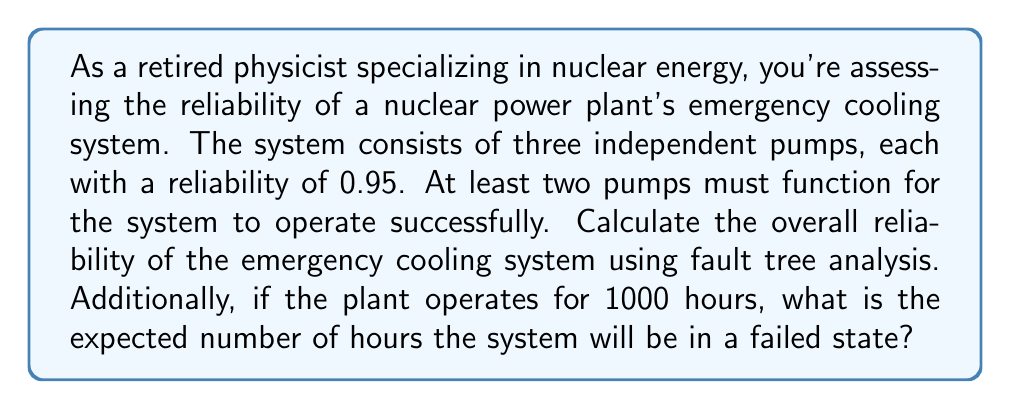Show me your answer to this math problem. Let's approach this problem step-by-step using fault tree analysis and probability theory:

1) First, we need to calculate the probability of system success. The system succeeds if either all three pumps work, or if any two out of three pumps work.

2) Probability of all three pumps working:
   $P(\text{all})$ = $0.95 \times 0.95 \times 0.95$ = $0.95^3$ = $0.857375$

3) Probability of exactly two pumps working:
   There are $\binom{3}{2} = 3$ ways to choose 2 pumps out of 3.
   $P(\text{two})$ = $3 \times 0.95^2 \times 0.05$ = $0.135375$

4) The total probability of system success is:
   $P(\text{success})$ = $P(\text{all}) + P(\text{two})$ = $0.857375 + 0.135375$ = $0.99275$

5) The reliability of the system is equal to the probability of success:
   Reliability = $0.99275$ or $99.275\%$

6) To find the expected number of hours the system will be in a failed state:
   Probability of failure = $1 - 0.99275$ = $0.00725$
   Expected hours of failure = $1000 \times 0.00725$ = $7.25$ hours

Therefore, in 1000 hours of operation, we expect the system to be in a failed state for 7.25 hours.
Answer: The overall reliability of the emergency cooling system is 0.99275 or 99.275%. In 1000 hours of operation, the system is expected to be in a failed state for 7.25 hours. 